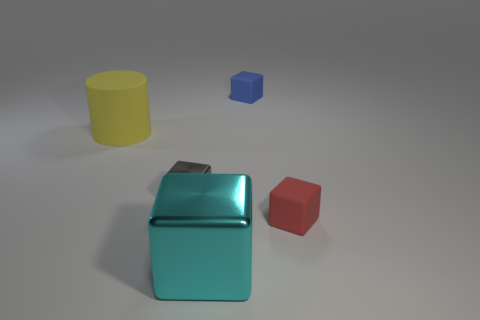Does the blue cube have the same size as the red matte thing?
Ensure brevity in your answer.  Yes. What number of large objects are matte cylinders or cyan shiny objects?
Give a very brief answer. 2. Does the tiny cube that is behind the tiny gray block have the same material as the small gray block?
Provide a succinct answer. No. The cyan block that is in front of the tiny rubber cube that is behind the matte cube in front of the big rubber thing is made of what material?
Your answer should be compact. Metal. Is there anything else that has the same size as the red cube?
Give a very brief answer. Yes. What number of rubber things are small objects or blue cubes?
Keep it short and to the point. 2. Is there a cube?
Ensure brevity in your answer.  Yes. There is a tiny matte cube that is behind the large object left of the large cyan cube; what is its color?
Give a very brief answer. Blue. How many other things are there of the same color as the large shiny cube?
Offer a very short reply. 0. What number of objects are either small purple metallic cylinders or small gray blocks right of the rubber cylinder?
Offer a very short reply. 1. 